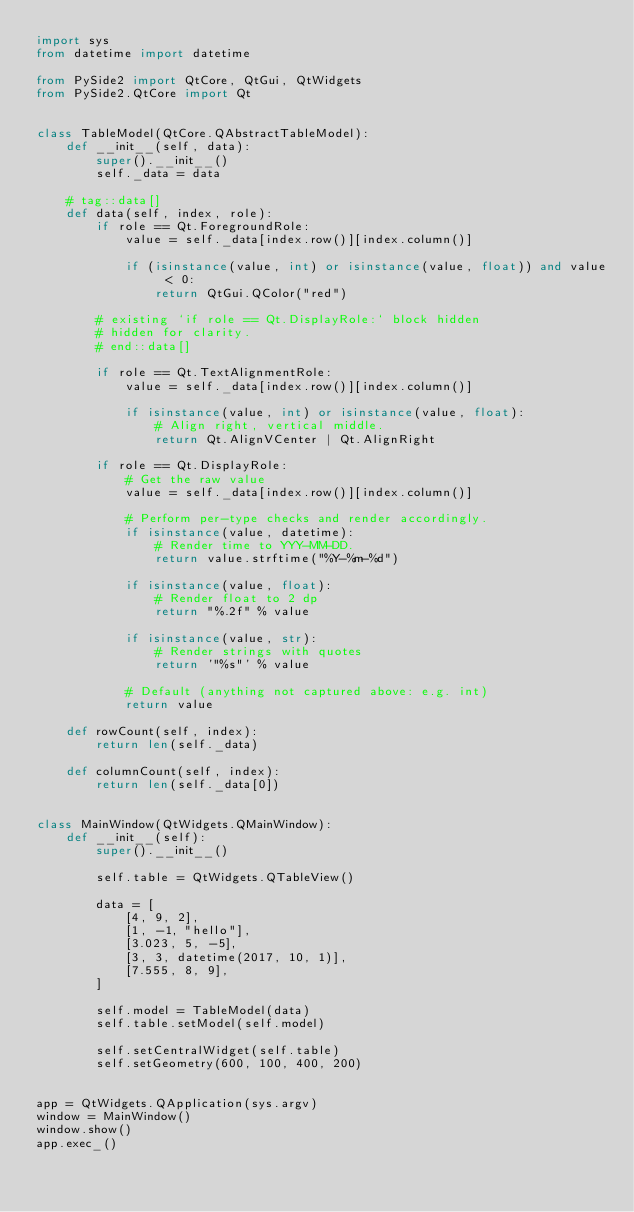<code> <loc_0><loc_0><loc_500><loc_500><_Python_>import sys
from datetime import datetime

from PySide2 import QtCore, QtGui, QtWidgets
from PySide2.QtCore import Qt


class TableModel(QtCore.QAbstractTableModel):
    def __init__(self, data):
        super().__init__()
        self._data = data

    # tag::data[]
    def data(self, index, role):
        if role == Qt.ForegroundRole:
            value = self._data[index.row()][index.column()]

            if (isinstance(value, int) or isinstance(value, float)) and value < 0:
                return QtGui.QColor("red")

        # existing `if role == Qt.DisplayRole:` block hidden
        # hidden for clarity.
        # end::data[]

        if role == Qt.TextAlignmentRole:
            value = self._data[index.row()][index.column()]

            if isinstance(value, int) or isinstance(value, float):
                # Align right, vertical middle.
                return Qt.AlignVCenter | Qt.AlignRight

        if role == Qt.DisplayRole:
            # Get the raw value
            value = self._data[index.row()][index.column()]

            # Perform per-type checks and render accordingly.
            if isinstance(value, datetime):
                # Render time to YYY-MM-DD.
                return value.strftime("%Y-%m-%d")

            if isinstance(value, float):
                # Render float to 2 dp
                return "%.2f" % value

            if isinstance(value, str):
                # Render strings with quotes
                return '"%s"' % value

            # Default (anything not captured above: e.g. int)
            return value

    def rowCount(self, index):
        return len(self._data)

    def columnCount(self, index):
        return len(self._data[0])


class MainWindow(QtWidgets.QMainWindow):
    def __init__(self):
        super().__init__()

        self.table = QtWidgets.QTableView()

        data = [
            [4, 9, 2],
            [1, -1, "hello"],
            [3.023, 5, -5],
            [3, 3, datetime(2017, 10, 1)],
            [7.555, 8, 9],
        ]

        self.model = TableModel(data)
        self.table.setModel(self.model)

        self.setCentralWidget(self.table)
        self.setGeometry(600, 100, 400, 200)


app = QtWidgets.QApplication(sys.argv)
window = MainWindow()
window.show()
app.exec_()
</code> 